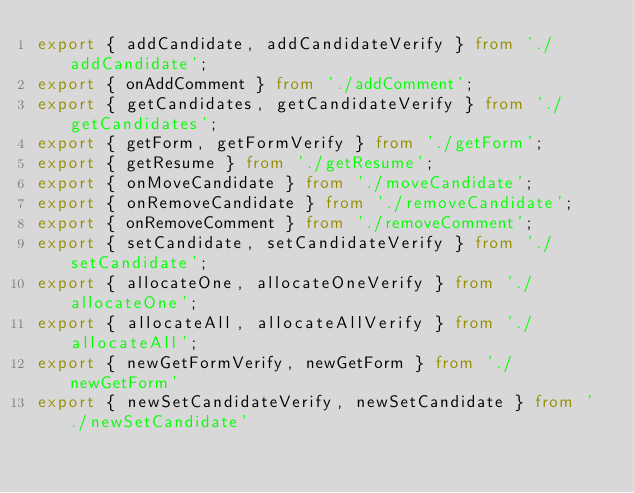Convert code to text. <code><loc_0><loc_0><loc_500><loc_500><_TypeScript_>export { addCandidate, addCandidateVerify } from './addCandidate';
export { onAddComment } from './addComment';
export { getCandidates, getCandidateVerify } from './getCandidates';
export { getForm, getFormVerify } from './getForm';
export { getResume } from './getResume';
export { onMoveCandidate } from './moveCandidate';
export { onRemoveCandidate } from './removeCandidate';
export { onRemoveComment } from './removeComment';
export { setCandidate, setCandidateVerify } from './setCandidate';
export { allocateOne, allocateOneVerify } from './allocateOne';
export { allocateAll, allocateAllVerify } from './allocateAll';
export { newGetFormVerify, newGetForm } from './newGetForm'
export { newSetCandidateVerify, newSetCandidate } from './newSetCandidate'</code> 